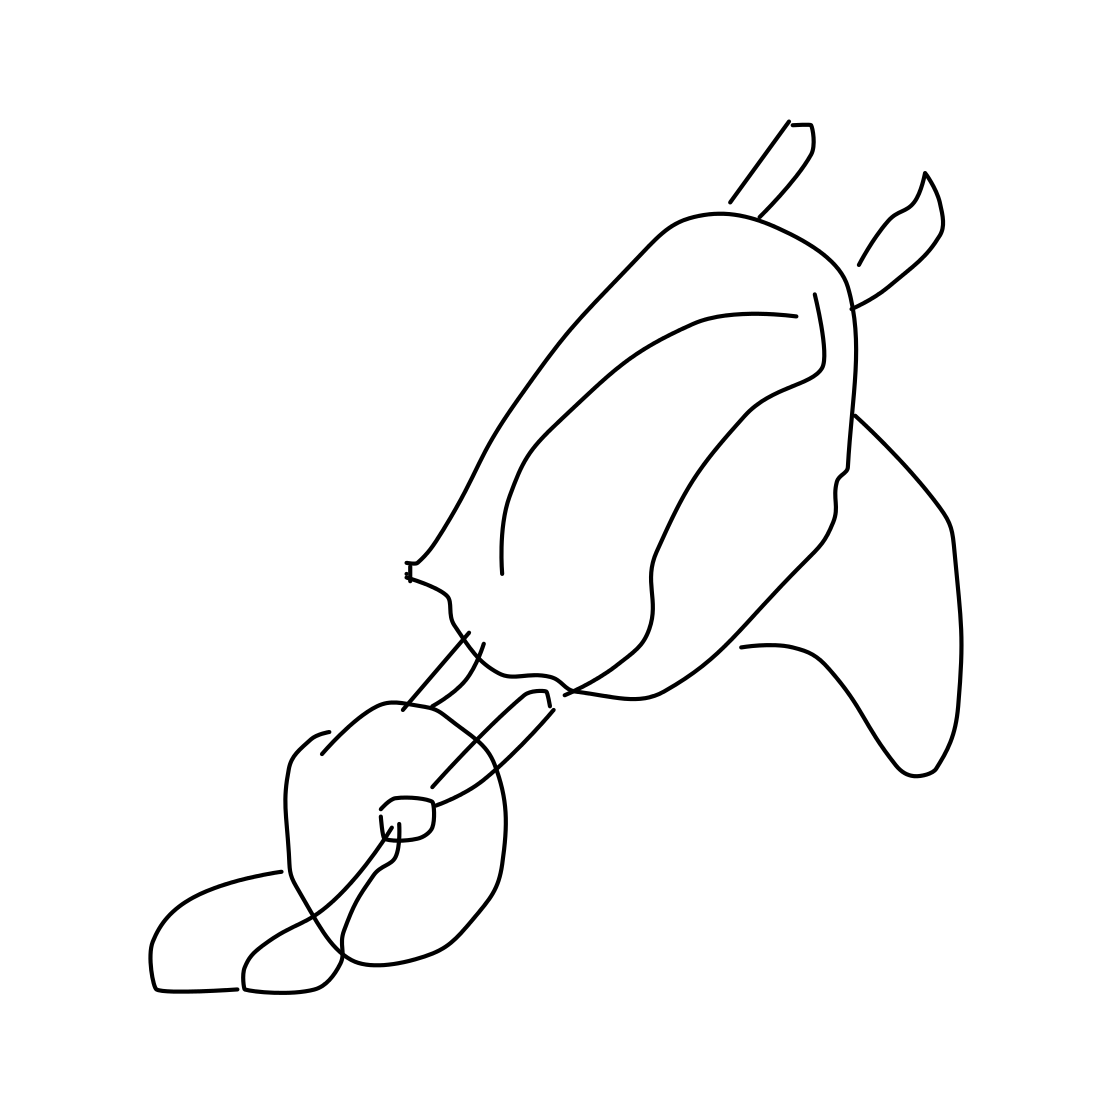What might this sketch tell us about the artist’s intention? The artist's use of minimal lines and abstraction might suggest a focus on conveying the concept of a wheelbarrow with as little detail as possible. It could reflect an artistic choice to prioritize the essence and form over intricate detail, or it might be an exercise in reducing objects to their most basic visual elements. Do you think the simplistic style could serve a functional purpose? Certainly, a simple and abstract style can be more universally understood, crossing language and cultural barriers. It might also be more adaptable to various design uses, such as icons, logos, or other graphic elements where clarity and immediate recognition are important. 